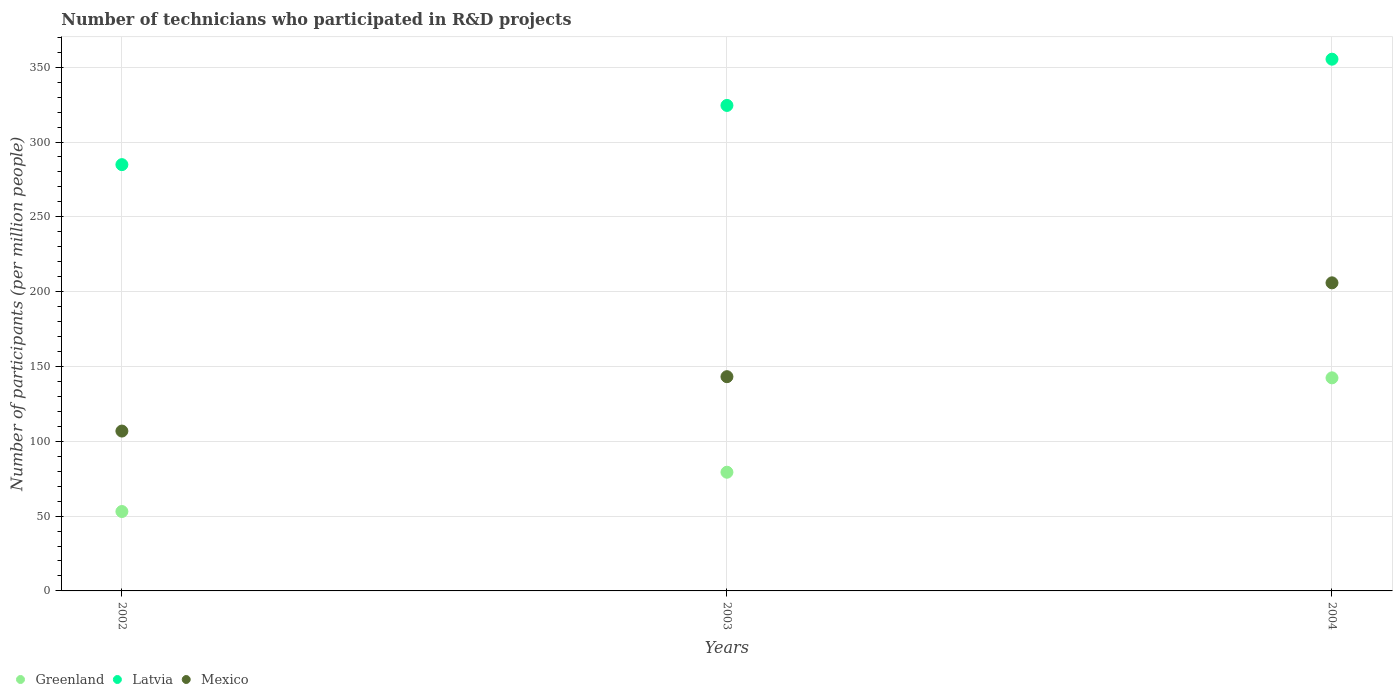Is the number of dotlines equal to the number of legend labels?
Provide a succinct answer. Yes. What is the number of technicians who participated in R&D projects in Mexico in 2002?
Keep it short and to the point. 106.83. Across all years, what is the maximum number of technicians who participated in R&D projects in Latvia?
Your answer should be very brief. 355.35. Across all years, what is the minimum number of technicians who participated in R&D projects in Latvia?
Your answer should be compact. 284.88. What is the total number of technicians who participated in R&D projects in Latvia in the graph?
Offer a terse response. 964.68. What is the difference between the number of technicians who participated in R&D projects in Mexico in 2002 and that in 2004?
Offer a terse response. -99.06. What is the difference between the number of technicians who participated in R&D projects in Mexico in 2004 and the number of technicians who participated in R&D projects in Latvia in 2002?
Provide a succinct answer. -79. What is the average number of technicians who participated in R&D projects in Mexico per year?
Your answer should be compact. 151.97. In the year 2002, what is the difference between the number of technicians who participated in R&D projects in Greenland and number of technicians who participated in R&D projects in Latvia?
Offer a terse response. -231.82. What is the ratio of the number of technicians who participated in R&D projects in Mexico in 2002 to that in 2004?
Your answer should be compact. 0.52. Is the difference between the number of technicians who participated in R&D projects in Greenland in 2002 and 2004 greater than the difference between the number of technicians who participated in R&D projects in Latvia in 2002 and 2004?
Make the answer very short. No. What is the difference between the highest and the second highest number of technicians who participated in R&D projects in Latvia?
Offer a very short reply. 30.9. What is the difference between the highest and the lowest number of technicians who participated in R&D projects in Greenland?
Your answer should be very brief. 89.34. Is the sum of the number of technicians who participated in R&D projects in Greenland in 2002 and 2004 greater than the maximum number of technicians who participated in R&D projects in Latvia across all years?
Provide a succinct answer. No. Is it the case that in every year, the sum of the number of technicians who participated in R&D projects in Greenland and number of technicians who participated in R&D projects in Latvia  is greater than the number of technicians who participated in R&D projects in Mexico?
Your answer should be compact. Yes. Does the number of technicians who participated in R&D projects in Latvia monotonically increase over the years?
Offer a terse response. Yes. Is the number of technicians who participated in R&D projects in Latvia strictly greater than the number of technicians who participated in R&D projects in Greenland over the years?
Ensure brevity in your answer.  Yes. Is the number of technicians who participated in R&D projects in Latvia strictly less than the number of technicians who participated in R&D projects in Greenland over the years?
Your response must be concise. No. How many years are there in the graph?
Provide a short and direct response. 3. How are the legend labels stacked?
Keep it short and to the point. Horizontal. What is the title of the graph?
Provide a succinct answer. Number of technicians who participated in R&D projects. Does "Heavily indebted poor countries" appear as one of the legend labels in the graph?
Your answer should be compact. No. What is the label or title of the X-axis?
Give a very brief answer. Years. What is the label or title of the Y-axis?
Ensure brevity in your answer.  Number of participants (per million people). What is the Number of participants (per million people) of Greenland in 2002?
Offer a very short reply. 53.07. What is the Number of participants (per million people) of Latvia in 2002?
Keep it short and to the point. 284.88. What is the Number of participants (per million people) of Mexico in 2002?
Make the answer very short. 106.83. What is the Number of participants (per million people) in Greenland in 2003?
Give a very brief answer. 79.32. What is the Number of participants (per million people) of Latvia in 2003?
Provide a succinct answer. 324.45. What is the Number of participants (per million people) of Mexico in 2003?
Offer a terse response. 143.18. What is the Number of participants (per million people) of Greenland in 2004?
Provide a succinct answer. 142.4. What is the Number of participants (per million people) of Latvia in 2004?
Give a very brief answer. 355.35. What is the Number of participants (per million people) of Mexico in 2004?
Make the answer very short. 205.89. Across all years, what is the maximum Number of participants (per million people) in Greenland?
Give a very brief answer. 142.4. Across all years, what is the maximum Number of participants (per million people) of Latvia?
Provide a succinct answer. 355.35. Across all years, what is the maximum Number of participants (per million people) in Mexico?
Give a very brief answer. 205.89. Across all years, what is the minimum Number of participants (per million people) of Greenland?
Your answer should be very brief. 53.07. Across all years, what is the minimum Number of participants (per million people) of Latvia?
Ensure brevity in your answer.  284.88. Across all years, what is the minimum Number of participants (per million people) of Mexico?
Give a very brief answer. 106.83. What is the total Number of participants (per million people) of Greenland in the graph?
Provide a succinct answer. 274.79. What is the total Number of participants (per million people) of Latvia in the graph?
Provide a succinct answer. 964.68. What is the total Number of participants (per million people) in Mexico in the graph?
Provide a short and direct response. 455.9. What is the difference between the Number of participants (per million people) in Greenland in 2002 and that in 2003?
Your answer should be compact. -26.25. What is the difference between the Number of participants (per million people) in Latvia in 2002 and that in 2003?
Give a very brief answer. -39.57. What is the difference between the Number of participants (per million people) in Mexico in 2002 and that in 2003?
Offer a terse response. -36.35. What is the difference between the Number of participants (per million people) in Greenland in 2002 and that in 2004?
Offer a very short reply. -89.34. What is the difference between the Number of participants (per million people) of Latvia in 2002 and that in 2004?
Your response must be concise. -70.47. What is the difference between the Number of participants (per million people) of Mexico in 2002 and that in 2004?
Offer a terse response. -99.06. What is the difference between the Number of participants (per million people) in Greenland in 2003 and that in 2004?
Give a very brief answer. -63.08. What is the difference between the Number of participants (per million people) in Latvia in 2003 and that in 2004?
Your response must be concise. -30.9. What is the difference between the Number of participants (per million people) in Mexico in 2003 and that in 2004?
Give a very brief answer. -62.71. What is the difference between the Number of participants (per million people) of Greenland in 2002 and the Number of participants (per million people) of Latvia in 2003?
Ensure brevity in your answer.  -271.38. What is the difference between the Number of participants (per million people) of Greenland in 2002 and the Number of participants (per million people) of Mexico in 2003?
Make the answer very short. -90.11. What is the difference between the Number of participants (per million people) of Latvia in 2002 and the Number of participants (per million people) of Mexico in 2003?
Provide a succinct answer. 141.71. What is the difference between the Number of participants (per million people) of Greenland in 2002 and the Number of participants (per million people) of Latvia in 2004?
Provide a short and direct response. -302.28. What is the difference between the Number of participants (per million people) in Greenland in 2002 and the Number of participants (per million people) in Mexico in 2004?
Make the answer very short. -152.82. What is the difference between the Number of participants (per million people) in Latvia in 2002 and the Number of participants (per million people) in Mexico in 2004?
Provide a short and direct response. 79. What is the difference between the Number of participants (per million people) in Greenland in 2003 and the Number of participants (per million people) in Latvia in 2004?
Offer a terse response. -276.03. What is the difference between the Number of participants (per million people) of Greenland in 2003 and the Number of participants (per million people) of Mexico in 2004?
Your answer should be compact. -126.57. What is the difference between the Number of participants (per million people) in Latvia in 2003 and the Number of participants (per million people) in Mexico in 2004?
Make the answer very short. 118.56. What is the average Number of participants (per million people) of Greenland per year?
Your response must be concise. 91.6. What is the average Number of participants (per million people) of Latvia per year?
Offer a terse response. 321.56. What is the average Number of participants (per million people) in Mexico per year?
Make the answer very short. 151.97. In the year 2002, what is the difference between the Number of participants (per million people) in Greenland and Number of participants (per million people) in Latvia?
Give a very brief answer. -231.82. In the year 2002, what is the difference between the Number of participants (per million people) of Greenland and Number of participants (per million people) of Mexico?
Keep it short and to the point. -53.77. In the year 2002, what is the difference between the Number of participants (per million people) in Latvia and Number of participants (per million people) in Mexico?
Make the answer very short. 178.05. In the year 2003, what is the difference between the Number of participants (per million people) in Greenland and Number of participants (per million people) in Latvia?
Your answer should be very brief. -245.13. In the year 2003, what is the difference between the Number of participants (per million people) in Greenland and Number of participants (per million people) in Mexico?
Keep it short and to the point. -63.86. In the year 2003, what is the difference between the Number of participants (per million people) in Latvia and Number of participants (per million people) in Mexico?
Keep it short and to the point. 181.27. In the year 2004, what is the difference between the Number of participants (per million people) in Greenland and Number of participants (per million people) in Latvia?
Provide a succinct answer. -212.95. In the year 2004, what is the difference between the Number of participants (per million people) of Greenland and Number of participants (per million people) of Mexico?
Your response must be concise. -63.49. In the year 2004, what is the difference between the Number of participants (per million people) in Latvia and Number of participants (per million people) in Mexico?
Make the answer very short. 149.46. What is the ratio of the Number of participants (per million people) in Greenland in 2002 to that in 2003?
Offer a terse response. 0.67. What is the ratio of the Number of participants (per million people) in Latvia in 2002 to that in 2003?
Your answer should be compact. 0.88. What is the ratio of the Number of participants (per million people) in Mexico in 2002 to that in 2003?
Your answer should be compact. 0.75. What is the ratio of the Number of participants (per million people) in Greenland in 2002 to that in 2004?
Give a very brief answer. 0.37. What is the ratio of the Number of participants (per million people) in Latvia in 2002 to that in 2004?
Your answer should be compact. 0.8. What is the ratio of the Number of participants (per million people) in Mexico in 2002 to that in 2004?
Provide a succinct answer. 0.52. What is the ratio of the Number of participants (per million people) in Greenland in 2003 to that in 2004?
Your response must be concise. 0.56. What is the ratio of the Number of participants (per million people) of Latvia in 2003 to that in 2004?
Your response must be concise. 0.91. What is the ratio of the Number of participants (per million people) of Mexico in 2003 to that in 2004?
Offer a very short reply. 0.7. What is the difference between the highest and the second highest Number of participants (per million people) of Greenland?
Your response must be concise. 63.08. What is the difference between the highest and the second highest Number of participants (per million people) in Latvia?
Give a very brief answer. 30.9. What is the difference between the highest and the second highest Number of participants (per million people) in Mexico?
Your answer should be compact. 62.71. What is the difference between the highest and the lowest Number of participants (per million people) in Greenland?
Provide a short and direct response. 89.34. What is the difference between the highest and the lowest Number of participants (per million people) of Latvia?
Give a very brief answer. 70.47. What is the difference between the highest and the lowest Number of participants (per million people) of Mexico?
Your answer should be compact. 99.06. 